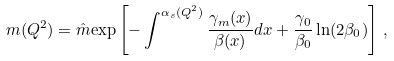Convert formula to latex. <formula><loc_0><loc_0><loc_500><loc_500>m ( Q ^ { 2 } ) = \hat { m } { \exp } \left [ - \int ^ { \alpha _ { s } ( Q ^ { 2 } ) } \frac { \gamma _ { m } ( x ) } { \beta ( x ) } d x + \frac { \gamma _ { 0 } } { \beta _ { 0 } } \ln ( 2 \beta _ { 0 } ) \right ] \, ,</formula> 